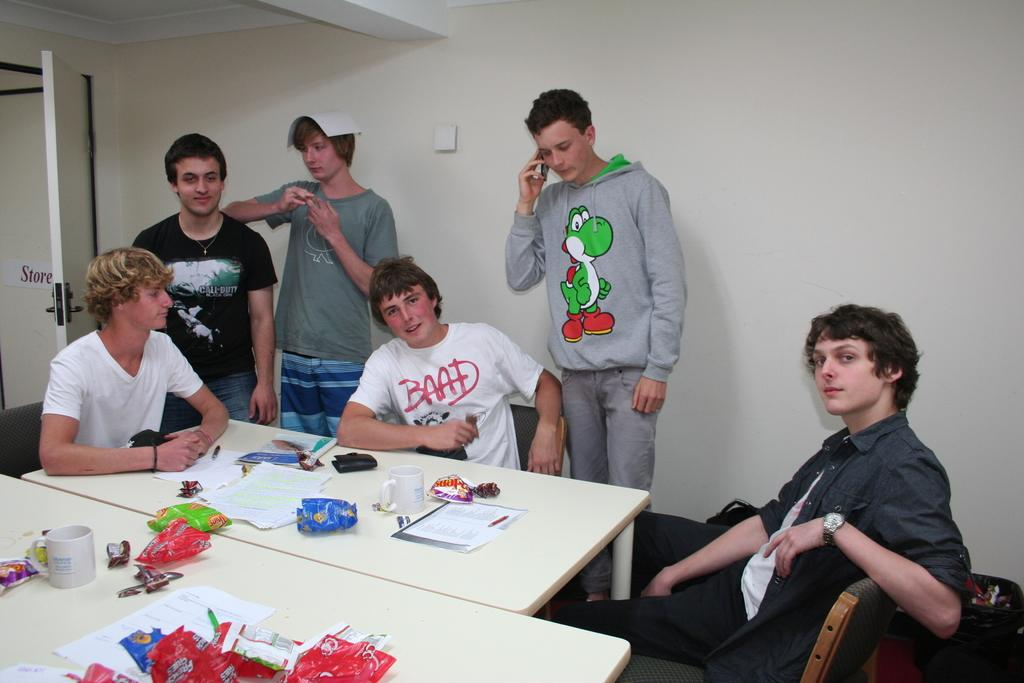How many people are in the image? There is a group of persons in the image. What are the people in the image doing? Some of the persons are sitting, while others are standing. What is located in the foreground of the image? There is a table in the foreground of the image. What can be found on the table? There are snacks and coffee cups on the table. What type of beef is being tied into a knot in the image? There is no beef or knot present in the image. How does the drop of water affect the group of persons in the image? There is no mention of a drop of water in the image, so its effect cannot be determined. 